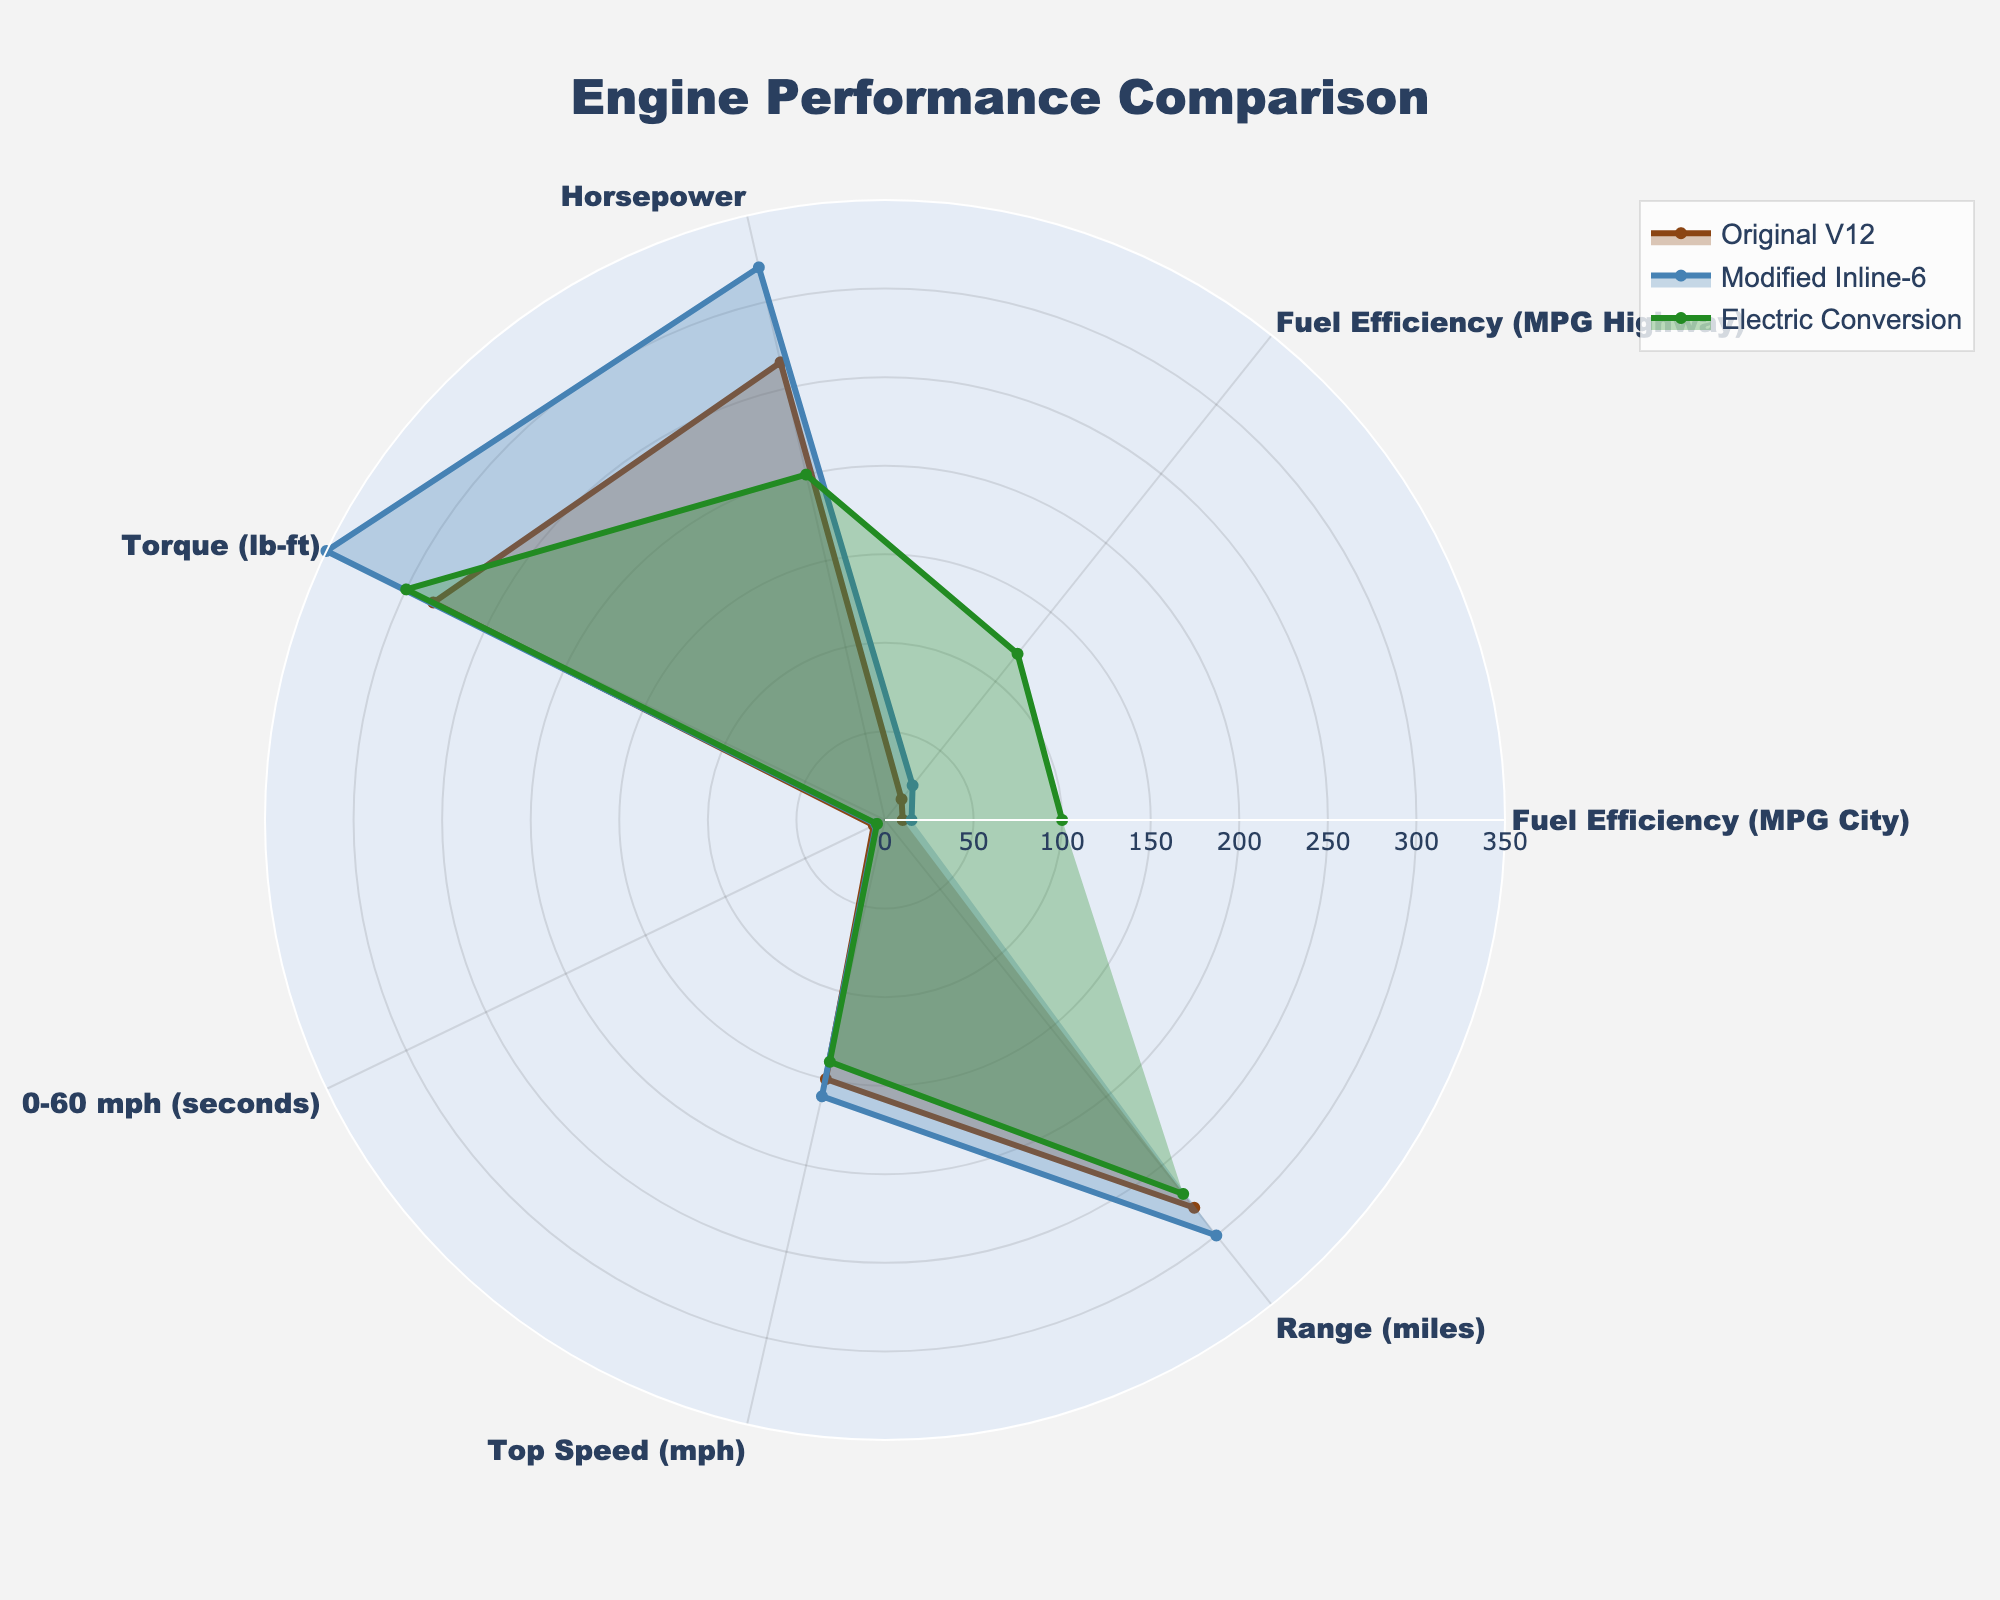what's the title of the radar chart? The title is displayed at the top center of the radar chart. It is meant to describe what the chart represents.
Answer: Engine Performance Comparison how many categories are being compared in the radar chart? The categories are listed around the radar chart, each representing a different metric of comparison for the engines.
Answer: 7 which engine type shows the highest fuel efficiency in the city? By looking at the "Fuel Efficiency (MPG City)" category, we can compare the heights of the lines for each engine.
Answer: Electric Conversion what is the difference in horsepower between the Original V12 and the Modified Inline-6? From the "Horsepower" metrics, the Original V12 has 265 horsepower, and the Modified Inline-6 has 320 horsepower. The difference is 320 - 265.
Answer: 55 between the Modified Inline-6 and the Electric Conversion, which has a quicker acceleration (0-60 mph)? In the "0-60 mph (seconds)" category, a lower value indicates quicker acceleration. The Modified Inline-6 takes 5.5 seconds, and the Electric Conversion takes 5.0 seconds.
Answer: Electric Conversion what is the average top speed across all three engine types? The top speeds are 150 mph for Original V12, 160 mph for Modified Inline-6, and 140 mph for Electric Conversion. The average is calculated as (150 + 160 + 140) / 3.
Answer: 150 which engine type has the lowest torque? In the "Torque (lb-ft)" category, compare the values for each engine type. The Original V12 has 283 lb-ft, Modified Inline-6 has 350 lb-ft, and Electric Conversion has 300 lb-ft.
Answer: Original V12 does the Electric Conversion offer a better range than the Original V12? Compare the values in the "Range (miles)" category. The Original V12 has a range of 280 miles, and the Electric Conversion has a range of 270 miles.
Answer: No 